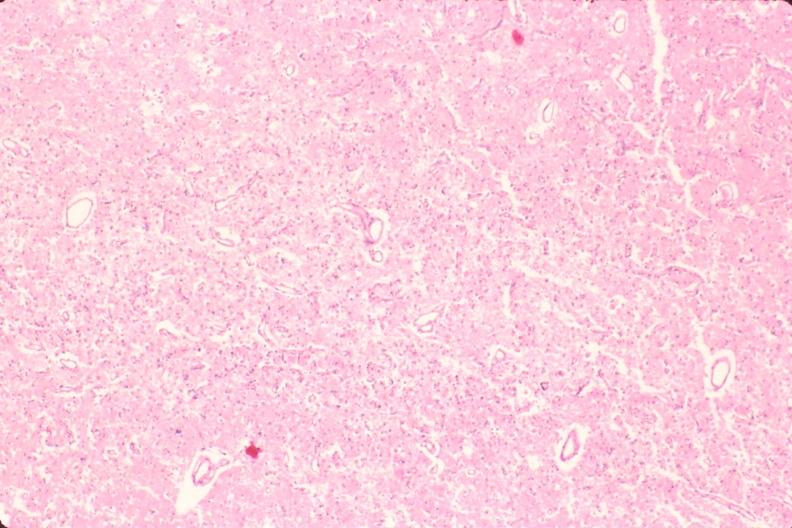does histoplasmosis show brain, old infarcts, embolic?
Answer the question using a single word or phrase. No 